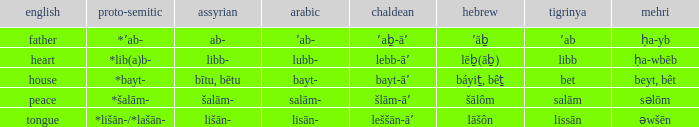If in arabic it is salām-, what is it in proto-semitic? *šalām-. 